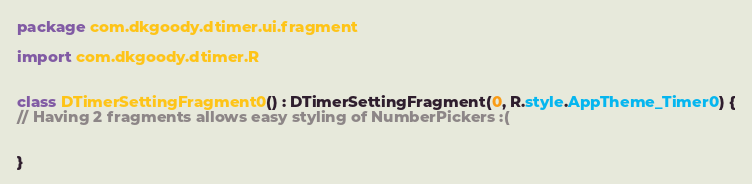<code> <loc_0><loc_0><loc_500><loc_500><_Kotlin_>package com.dkgoody.dtimer.ui.fragment

import com.dkgoody.dtimer.R


class DTimerSettingFragment0() : DTimerSettingFragment(0, R.style.AppTheme_Timer0) {
// Having 2 fragments allows easy styling of NumberPickers :(


}</code> 